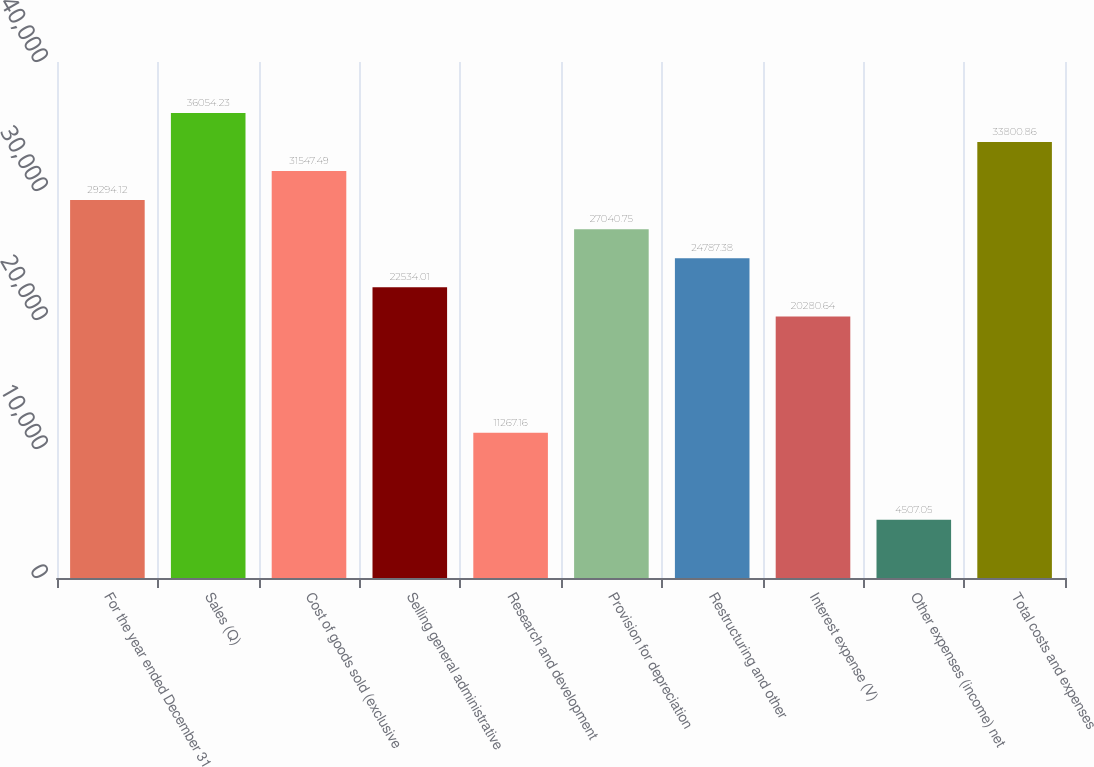<chart> <loc_0><loc_0><loc_500><loc_500><bar_chart><fcel>For the year ended December 31<fcel>Sales (Q)<fcel>Cost of goods sold (exclusive<fcel>Selling general administrative<fcel>Research and development<fcel>Provision for depreciation<fcel>Restructuring and other<fcel>Interest expense (V)<fcel>Other expenses (income) net<fcel>Total costs and expenses<nl><fcel>29294.1<fcel>36054.2<fcel>31547.5<fcel>22534<fcel>11267.2<fcel>27040.8<fcel>24787.4<fcel>20280.6<fcel>4507.05<fcel>33800.9<nl></chart> 